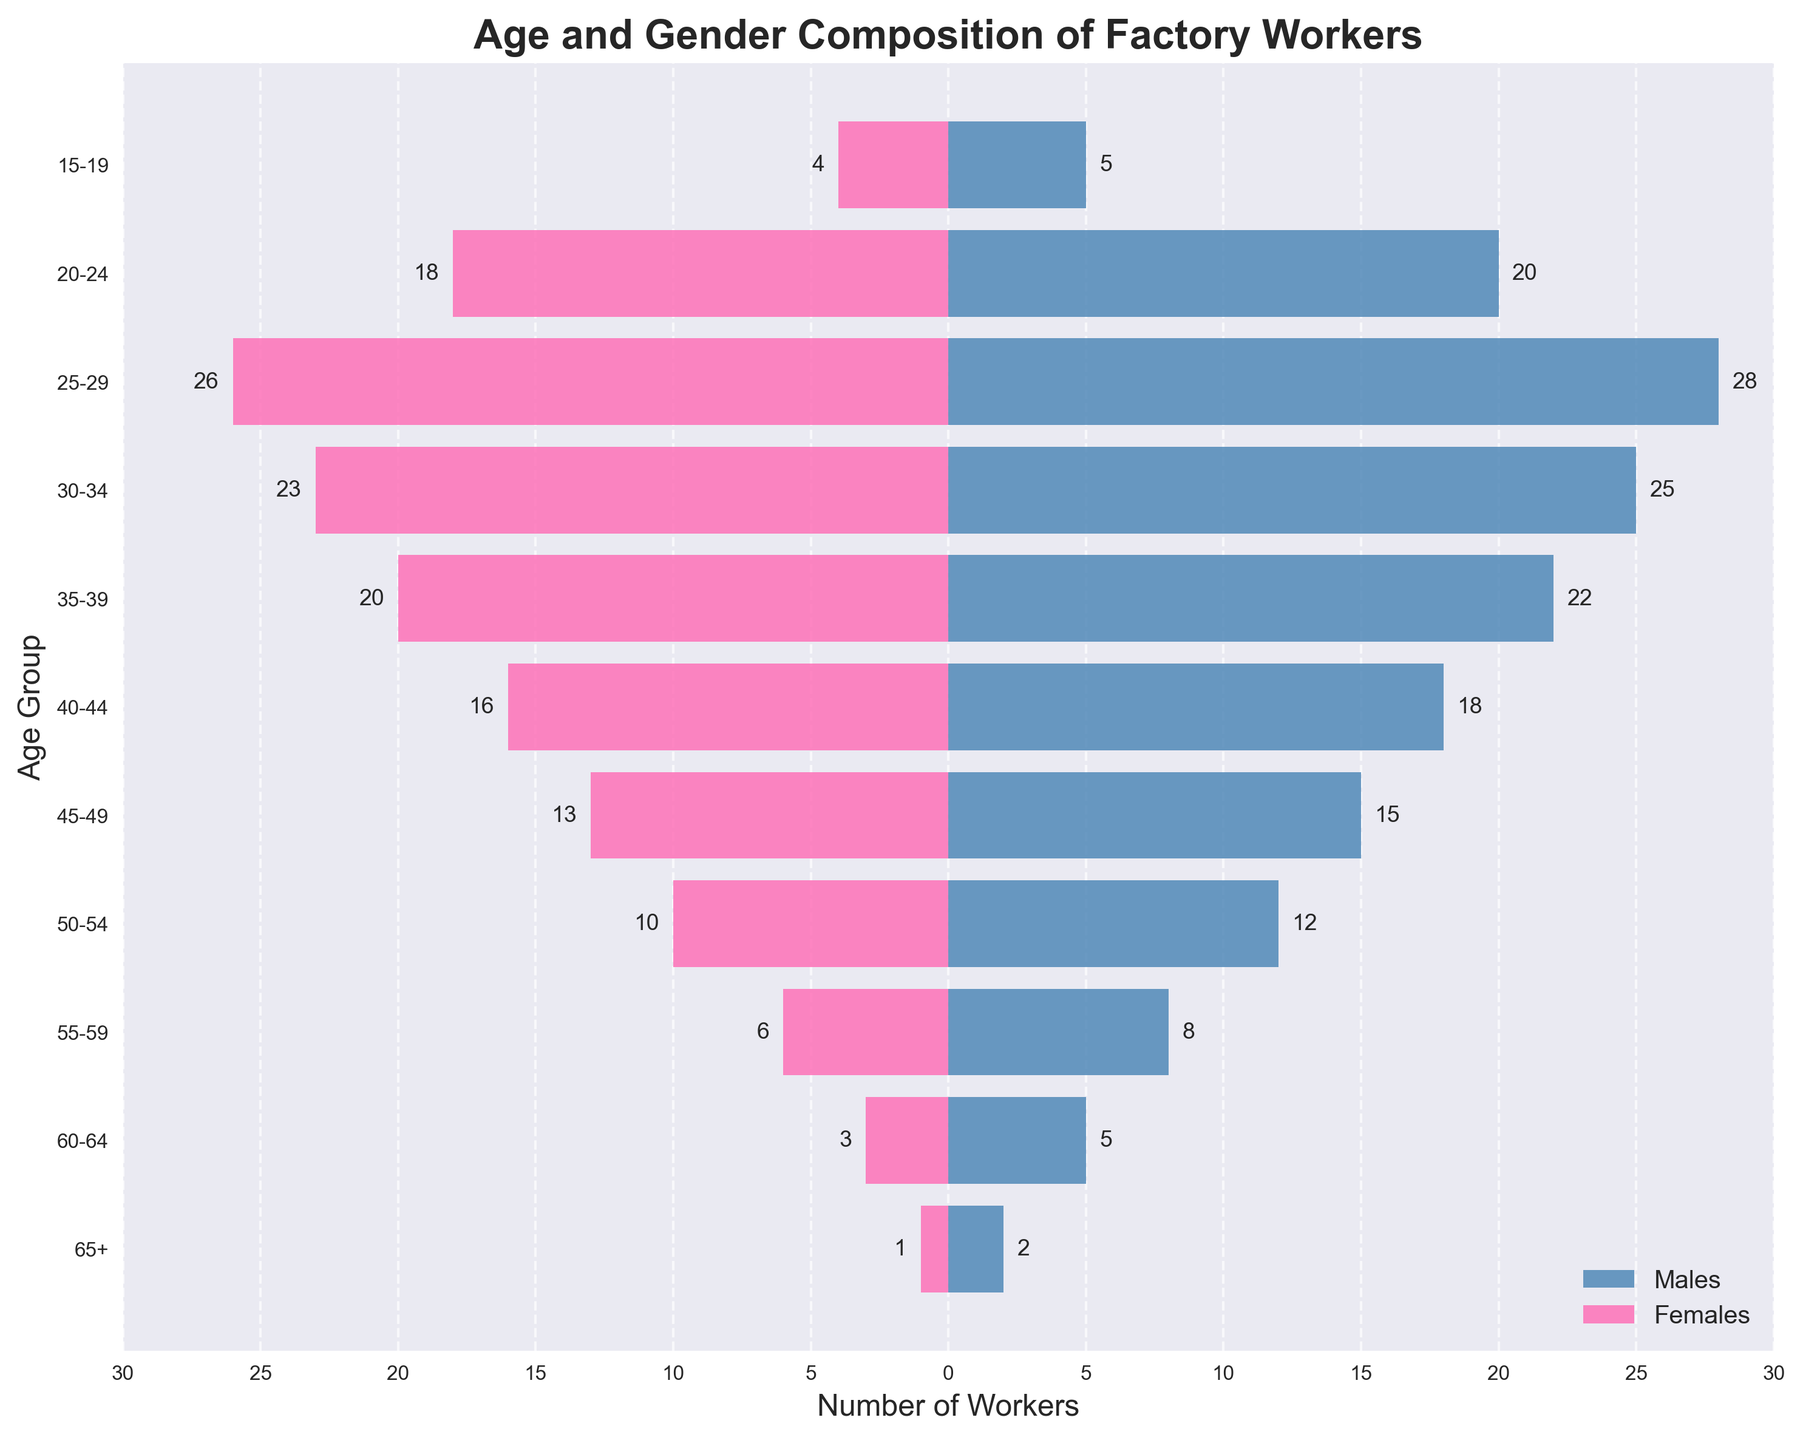Which age group has the highest number of male factory workers? The age group 25-29 has the highest number of male factory workers, as shown by the longest blue bar on the male side of the figure.
Answer: 25-29 Which age group has the lowest number of female factory workers? The age group 65+ has the lowest number of female factory workers, which is indicated by the shortest pink bar on the female side of the figure.
Answer: 65+ How many workers aged 60-64 are there in total? Sum the number of male and female workers in the 60-64 age group: 5 (males) + 3 (females) = 8 workers.
Answer: 8 Which gender has more workers in the 45-49 age group? In the 45-49 age group, there are 15 males and 13 females, so males outnumber females.
Answer: Males What is the difference between the number of male and female workers in the 35-39 age group? Subtract the number of female workers (20) from the number of male workers (22). 22 - 20 = 2.
Answer: 2 By how much do male workers in the 50-54 age group outnumber female workers? The 50-54 age group has 12 males and 10 females. The difference is 12 - 10 = 2.
Answer: 2 What is the total number of workers aged under 20? Add the numbers of male and female workers in the 15-19 age group: 5 (males) + 4 (females) = 9 workers.
Answer: 9 Is the number of workers decreasing or increasing as age increases? Observe the trend in the bar lengths. The number of workers generally decreases as the age increases, indicating an inverse relationship between age and number of workers.
Answer: Decreasing Which age group shows the closest male-to-female ratio? The 25-29 age group has 28 males and 26 females, the smallest difference of 2, indicating the closest male-to-female ratio.
Answer: 25-29 Between ages 20-24 and 30-34, which age group has a higher total number of workers? The total number of workers aged 20-24 is 20 (males) + 18 (females) = 38. The total number of workers aged 30-34 is 25 (males) + 23 (females) = 48. Thus, the 30-34 age group has a higher total.
Answer: 30-34 